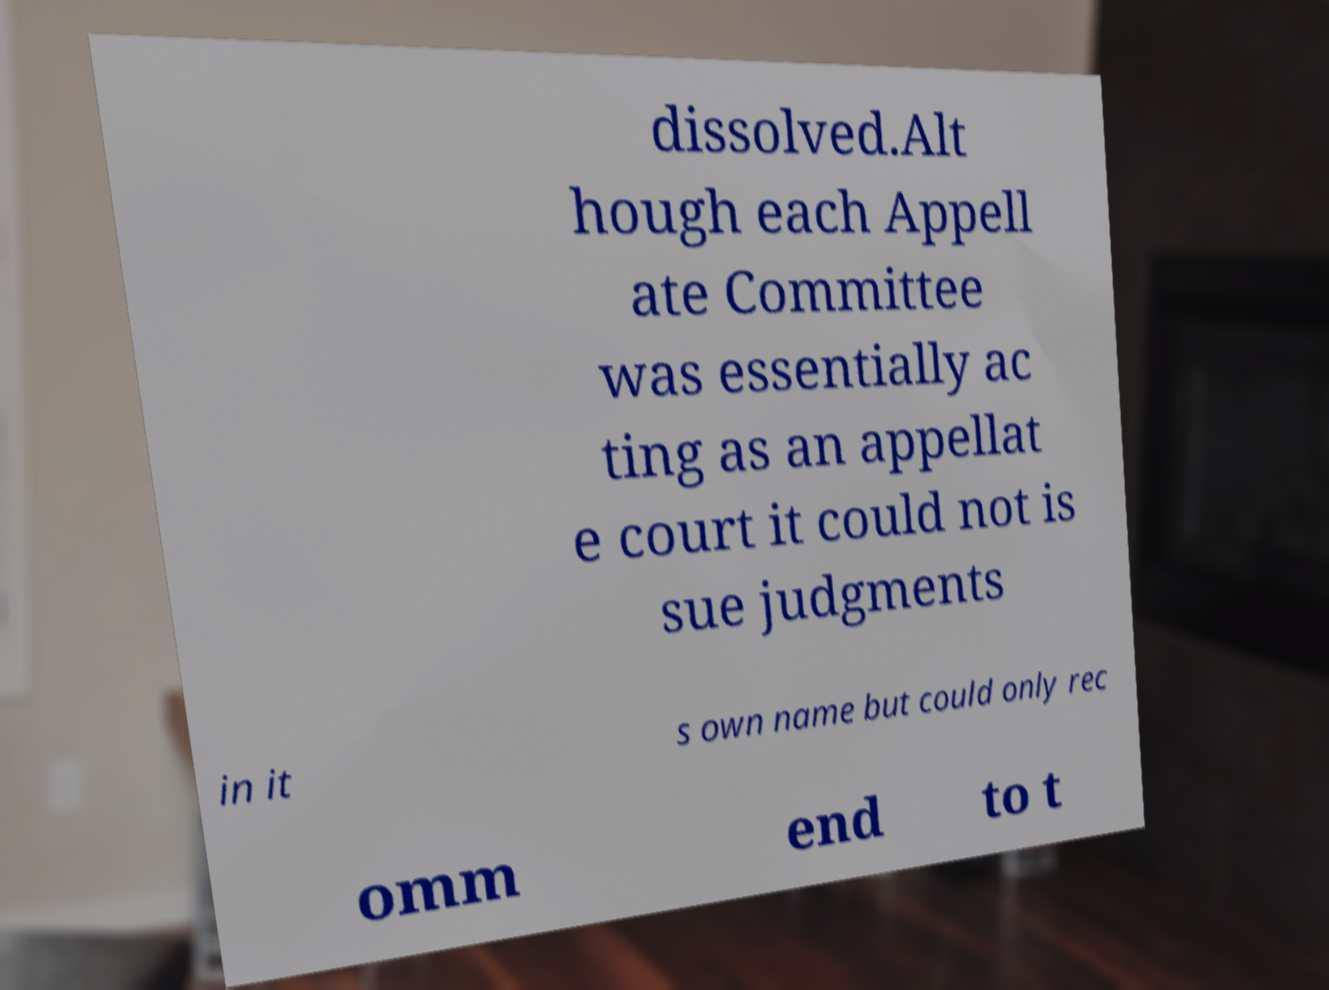There's text embedded in this image that I need extracted. Can you transcribe it verbatim? dissolved.Alt hough each Appell ate Committee was essentially ac ting as an appellat e court it could not is sue judgments in it s own name but could only rec omm end to t 